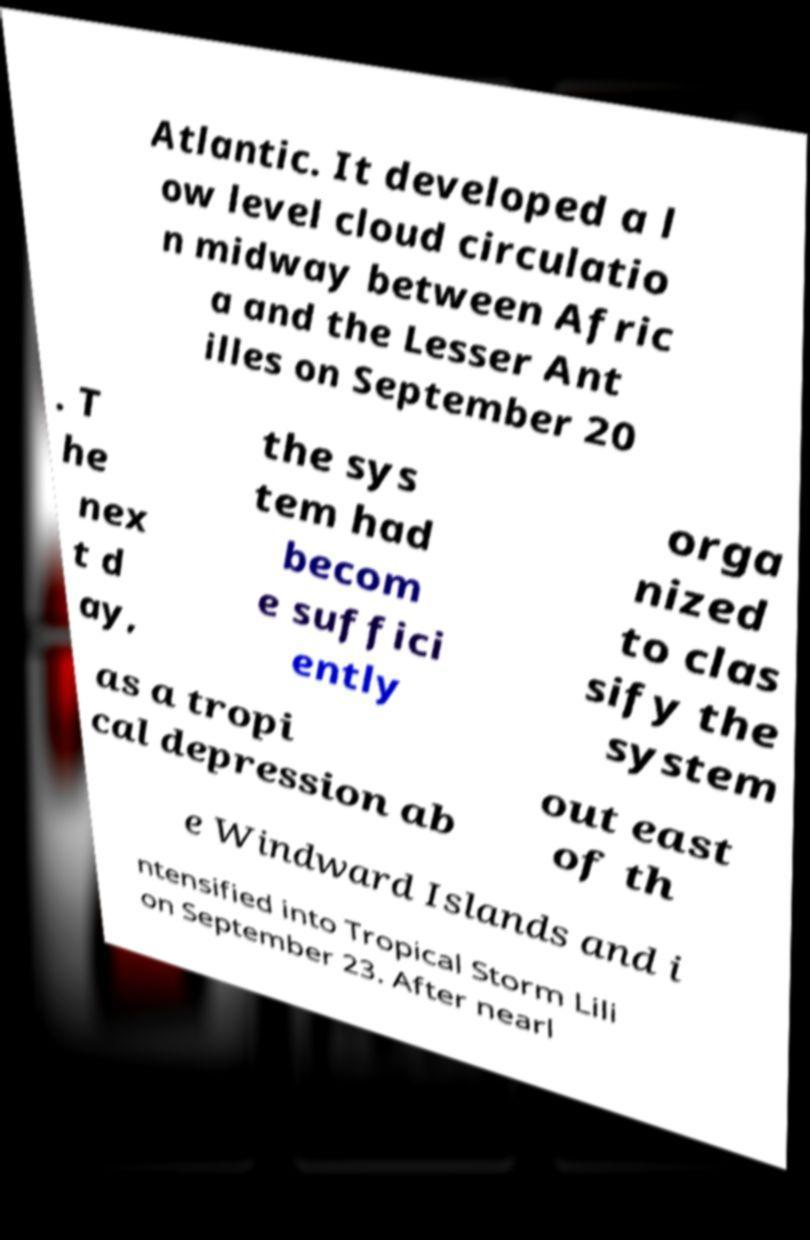Could you extract and type out the text from this image? Atlantic. It developed a l ow level cloud circulatio n midway between Afric a and the Lesser Ant illes on September 20 . T he nex t d ay, the sys tem had becom e suffici ently orga nized to clas sify the system as a tropi cal depression ab out east of th e Windward Islands and i ntensified into Tropical Storm Lili on September 23. After nearl 